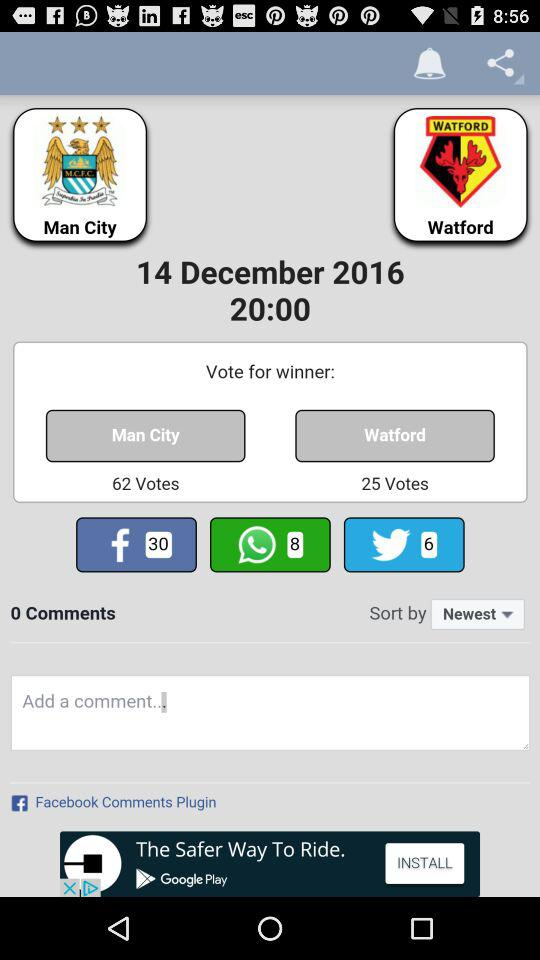How many votes are there in total?
Answer the question using a single word or phrase. 87 